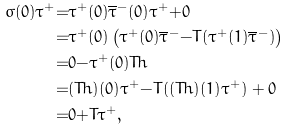<formula> <loc_0><loc_0><loc_500><loc_500>\sigma ( 0 ) \tau ^ { + } & { = } \tau ^ { + } ( 0 ) \overline { \tau } ^ { - } ( 0 ) \tau ^ { + } { + } 0 \\ & { = } \tau ^ { + } ( 0 ) \left ( \tau ^ { + } ( 0 ) \overline { \tau } ^ { - } { - } T ( \tau ^ { + } ( 1 ) \overline { \tau } ^ { - } ) \right ) \\ & { = } 0 { - } \tau ^ { + } ( 0 ) T h \\ & { = } ( T h ) ( 0 ) \tau ^ { + } { - } T ( ( T h ) ( 1 ) \tau ^ { + } ) + 0 \\ & { = } 0 { + } T \tau ^ { + } ,</formula> 